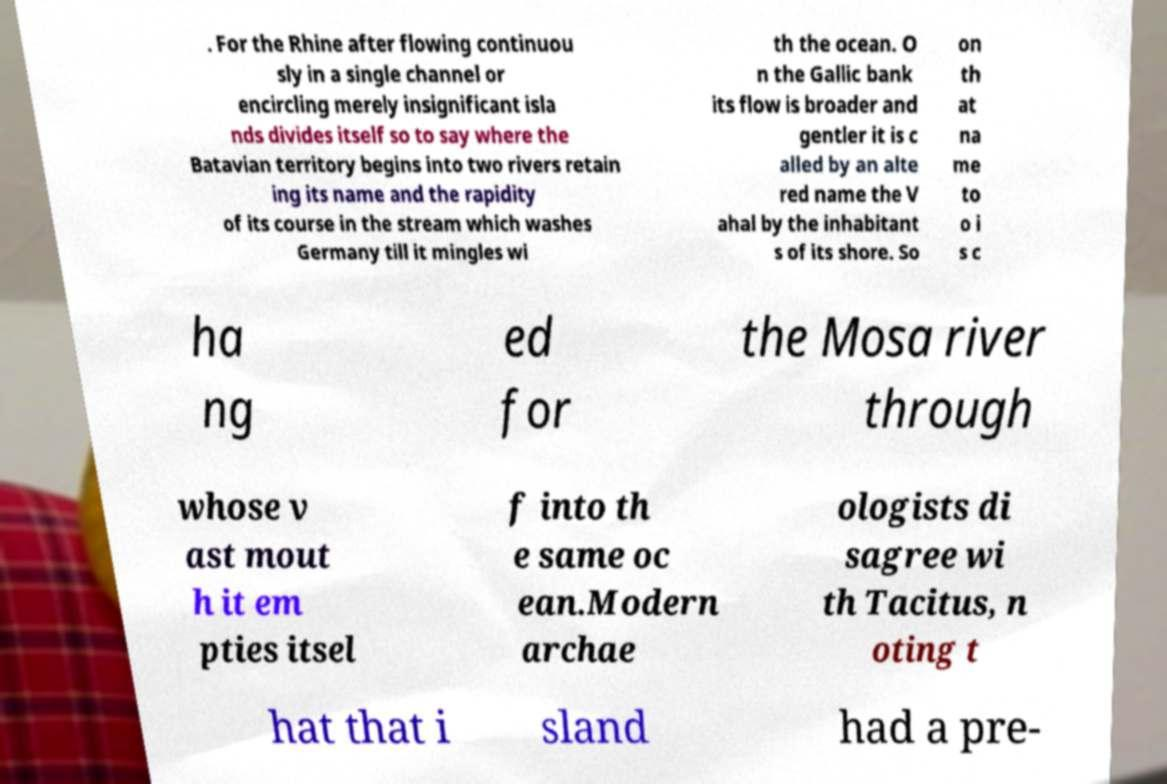Can you accurately transcribe the text from the provided image for me? . For the Rhine after flowing continuou sly in a single channel or encircling merely insignificant isla nds divides itself so to say where the Batavian territory begins into two rivers retain ing its name and the rapidity of its course in the stream which washes Germany till it mingles wi th the ocean. O n the Gallic bank its flow is broader and gentler it is c alled by an alte red name the V ahal by the inhabitant s of its shore. So on th at na me to o i s c ha ng ed for the Mosa river through whose v ast mout h it em pties itsel f into th e same oc ean.Modern archae ologists di sagree wi th Tacitus, n oting t hat that i sland had a pre- 